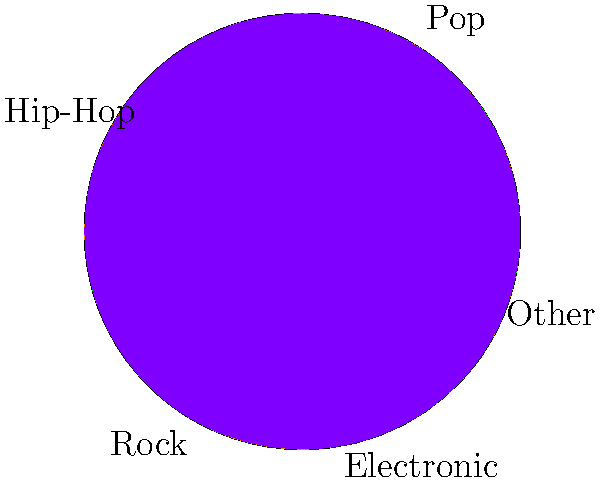As a music reviewer and content creator, you're analyzing the popularity of different music genres for your next YouTube video. The pie chart shows the distribution of music genres in the current market. If you were to create content focusing on the top two genres, what percentage of the market would your content potentially cover? To solve this problem, we need to follow these steps:

1. Identify the top two genres from the pie chart:
   - Pop: 30%
   - Hip-Hop: 25%

2. Add the percentages of these two genres:
   $30\% + 25\% = 55\%$

3. Convert the percentage to a decimal:
   $55\% = 0.55$ or $\frac{55}{100}$

Therefore, by focusing on Pop and Hip-Hop, your content would potentially cover 55% of the current music market.

This information is valuable for your YouTube channel as it helps you target the most popular genres, potentially increasing your viewership and engagement. You could use this data to plan your content strategy, such as allocating more time to reviewing and promoting albums from these genres or creating comparison videos between Pop and Hip-Hop artists.
Answer: 55% 